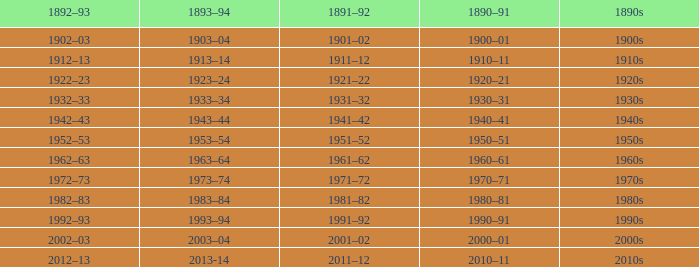What is the year from 1892-93 that has the 1890s to the 1940s? 1942–43. 